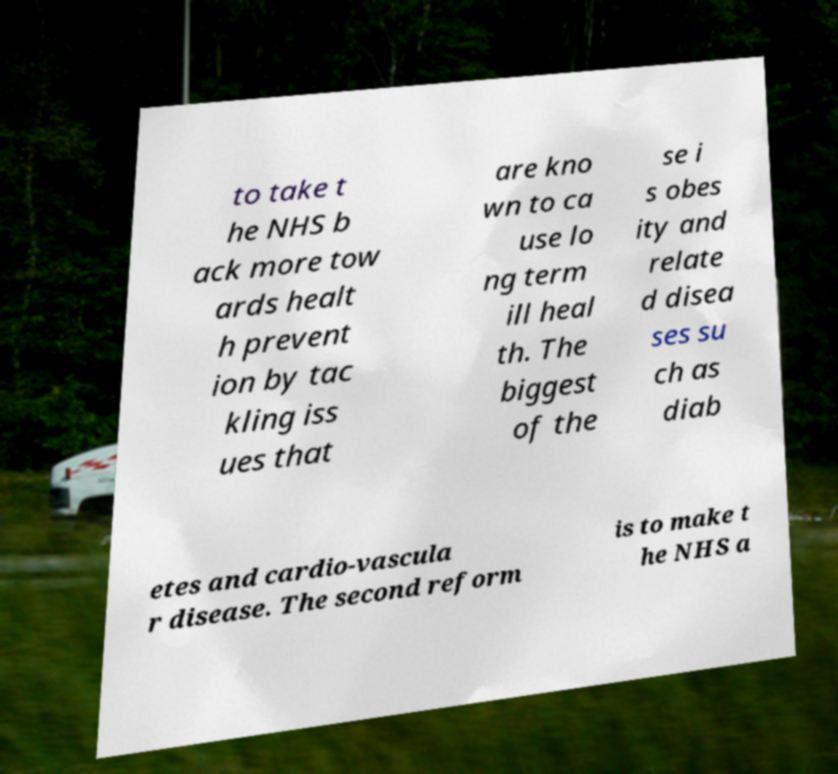Please read and relay the text visible in this image. What does it say? to take t he NHS b ack more tow ards healt h prevent ion by tac kling iss ues that are kno wn to ca use lo ng term ill heal th. The biggest of the se i s obes ity and relate d disea ses su ch as diab etes and cardio-vascula r disease. The second reform is to make t he NHS a 